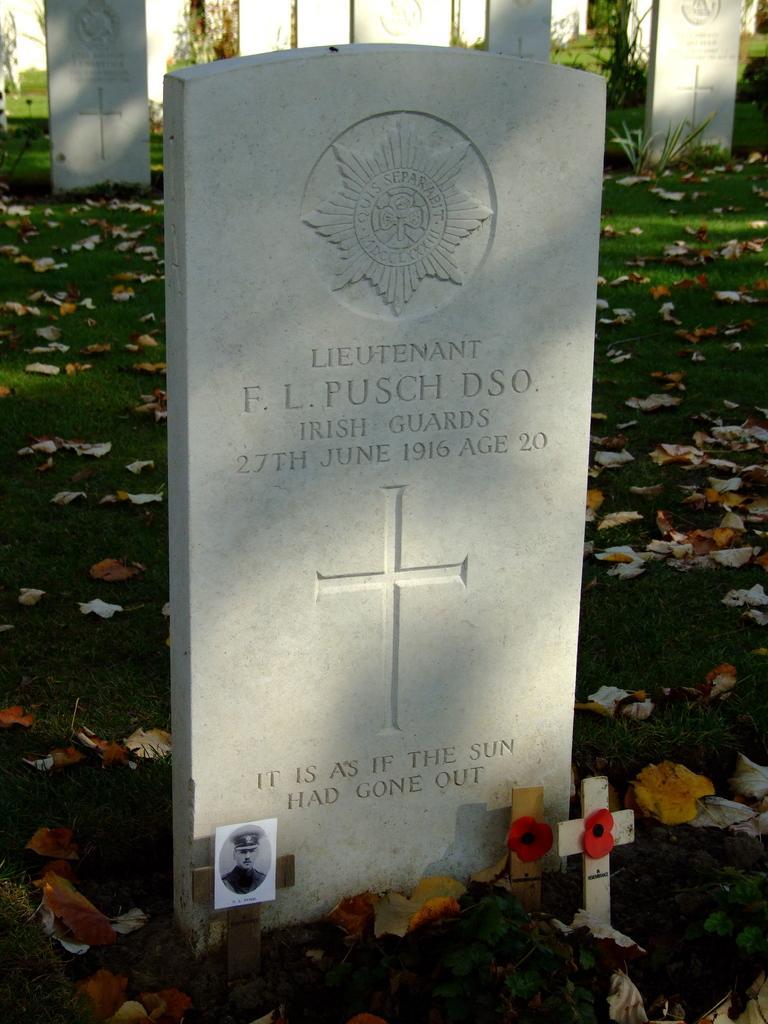Can you describe this image briefly? In this image, we can see graves with some text and logos and we can see cross. At the bottom, there is ground covered with leaves. 